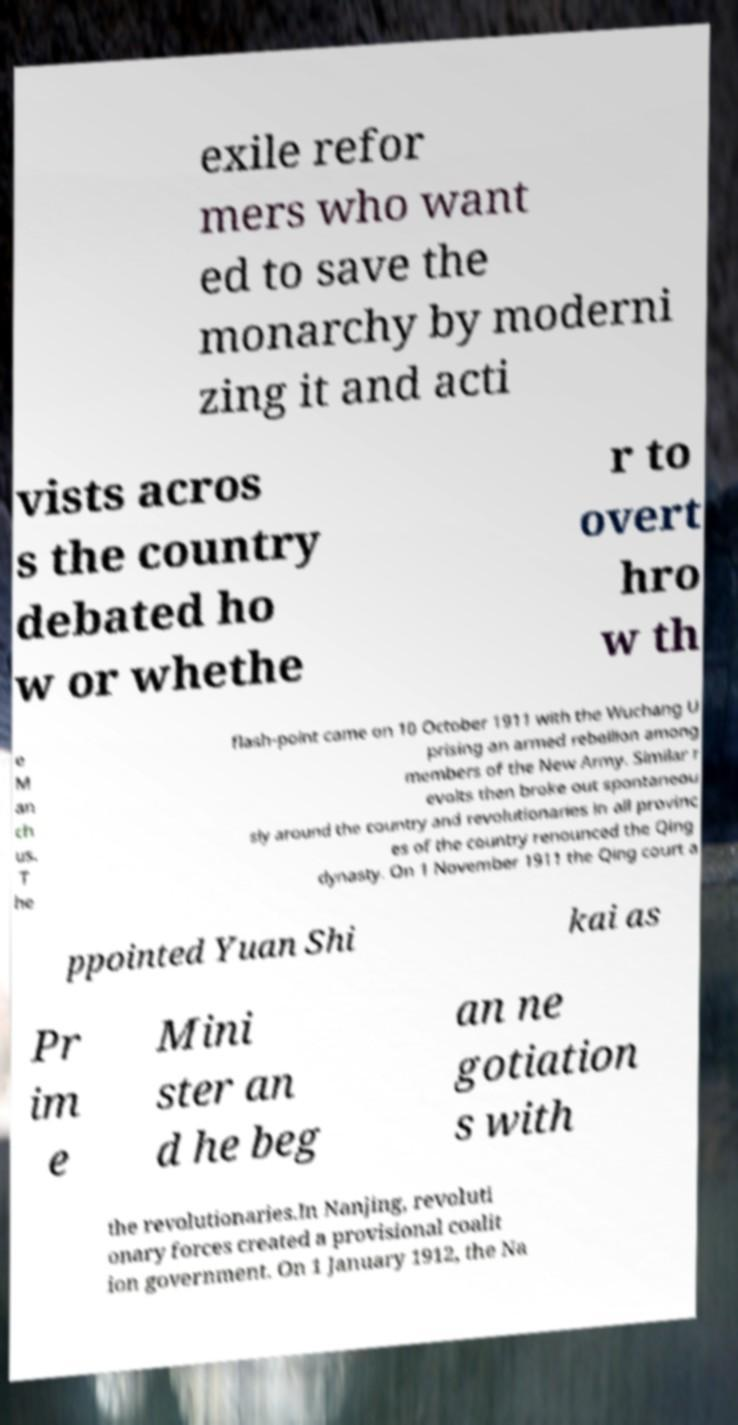Can you read and provide the text displayed in the image?This photo seems to have some interesting text. Can you extract and type it out for me? exile refor mers who want ed to save the monarchy by moderni zing it and acti vists acros s the country debated ho w or whethe r to overt hro w th e M an ch us. T he flash-point came on 10 October 1911 with the Wuchang U prising an armed rebellion among members of the New Army. Similar r evolts then broke out spontaneou sly around the country and revolutionaries in all provinc es of the country renounced the Qing dynasty. On 1 November 1911 the Qing court a ppointed Yuan Shi kai as Pr im e Mini ster an d he beg an ne gotiation s with the revolutionaries.In Nanjing, revoluti onary forces created a provisional coalit ion government. On 1 January 1912, the Na 